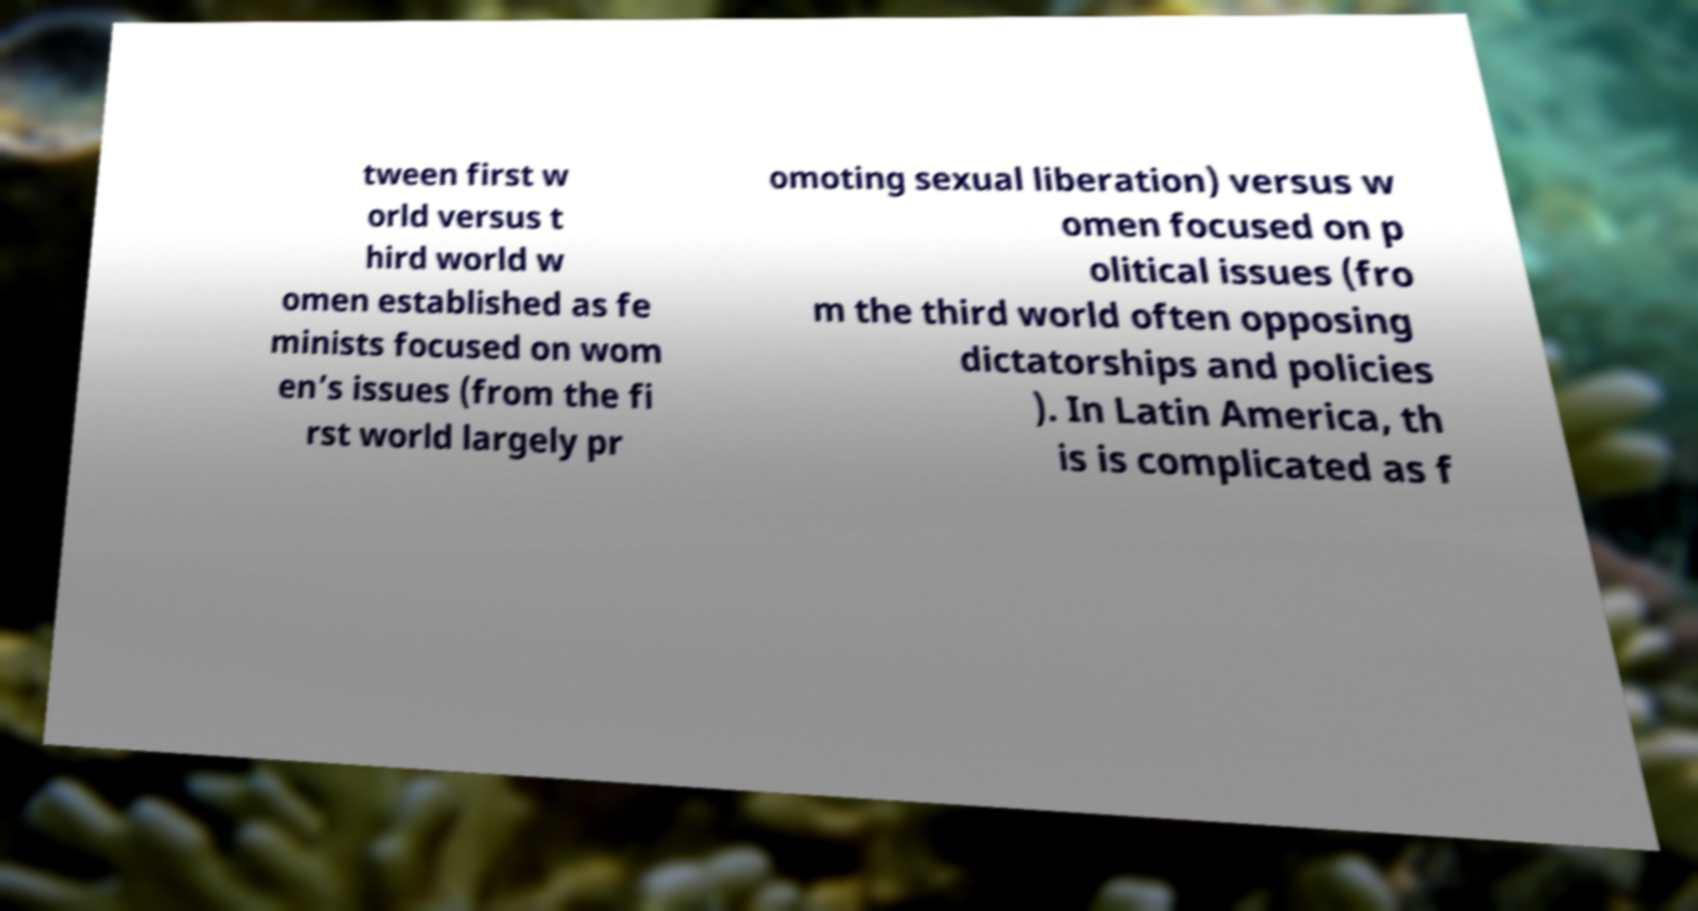Please identify and transcribe the text found in this image. tween first w orld versus t hird world w omen established as fe minists focused on wom en’s issues (from the fi rst world largely pr omoting sexual liberation) versus w omen focused on p olitical issues (fro m the third world often opposing dictatorships and policies ). In Latin America, th is is complicated as f 